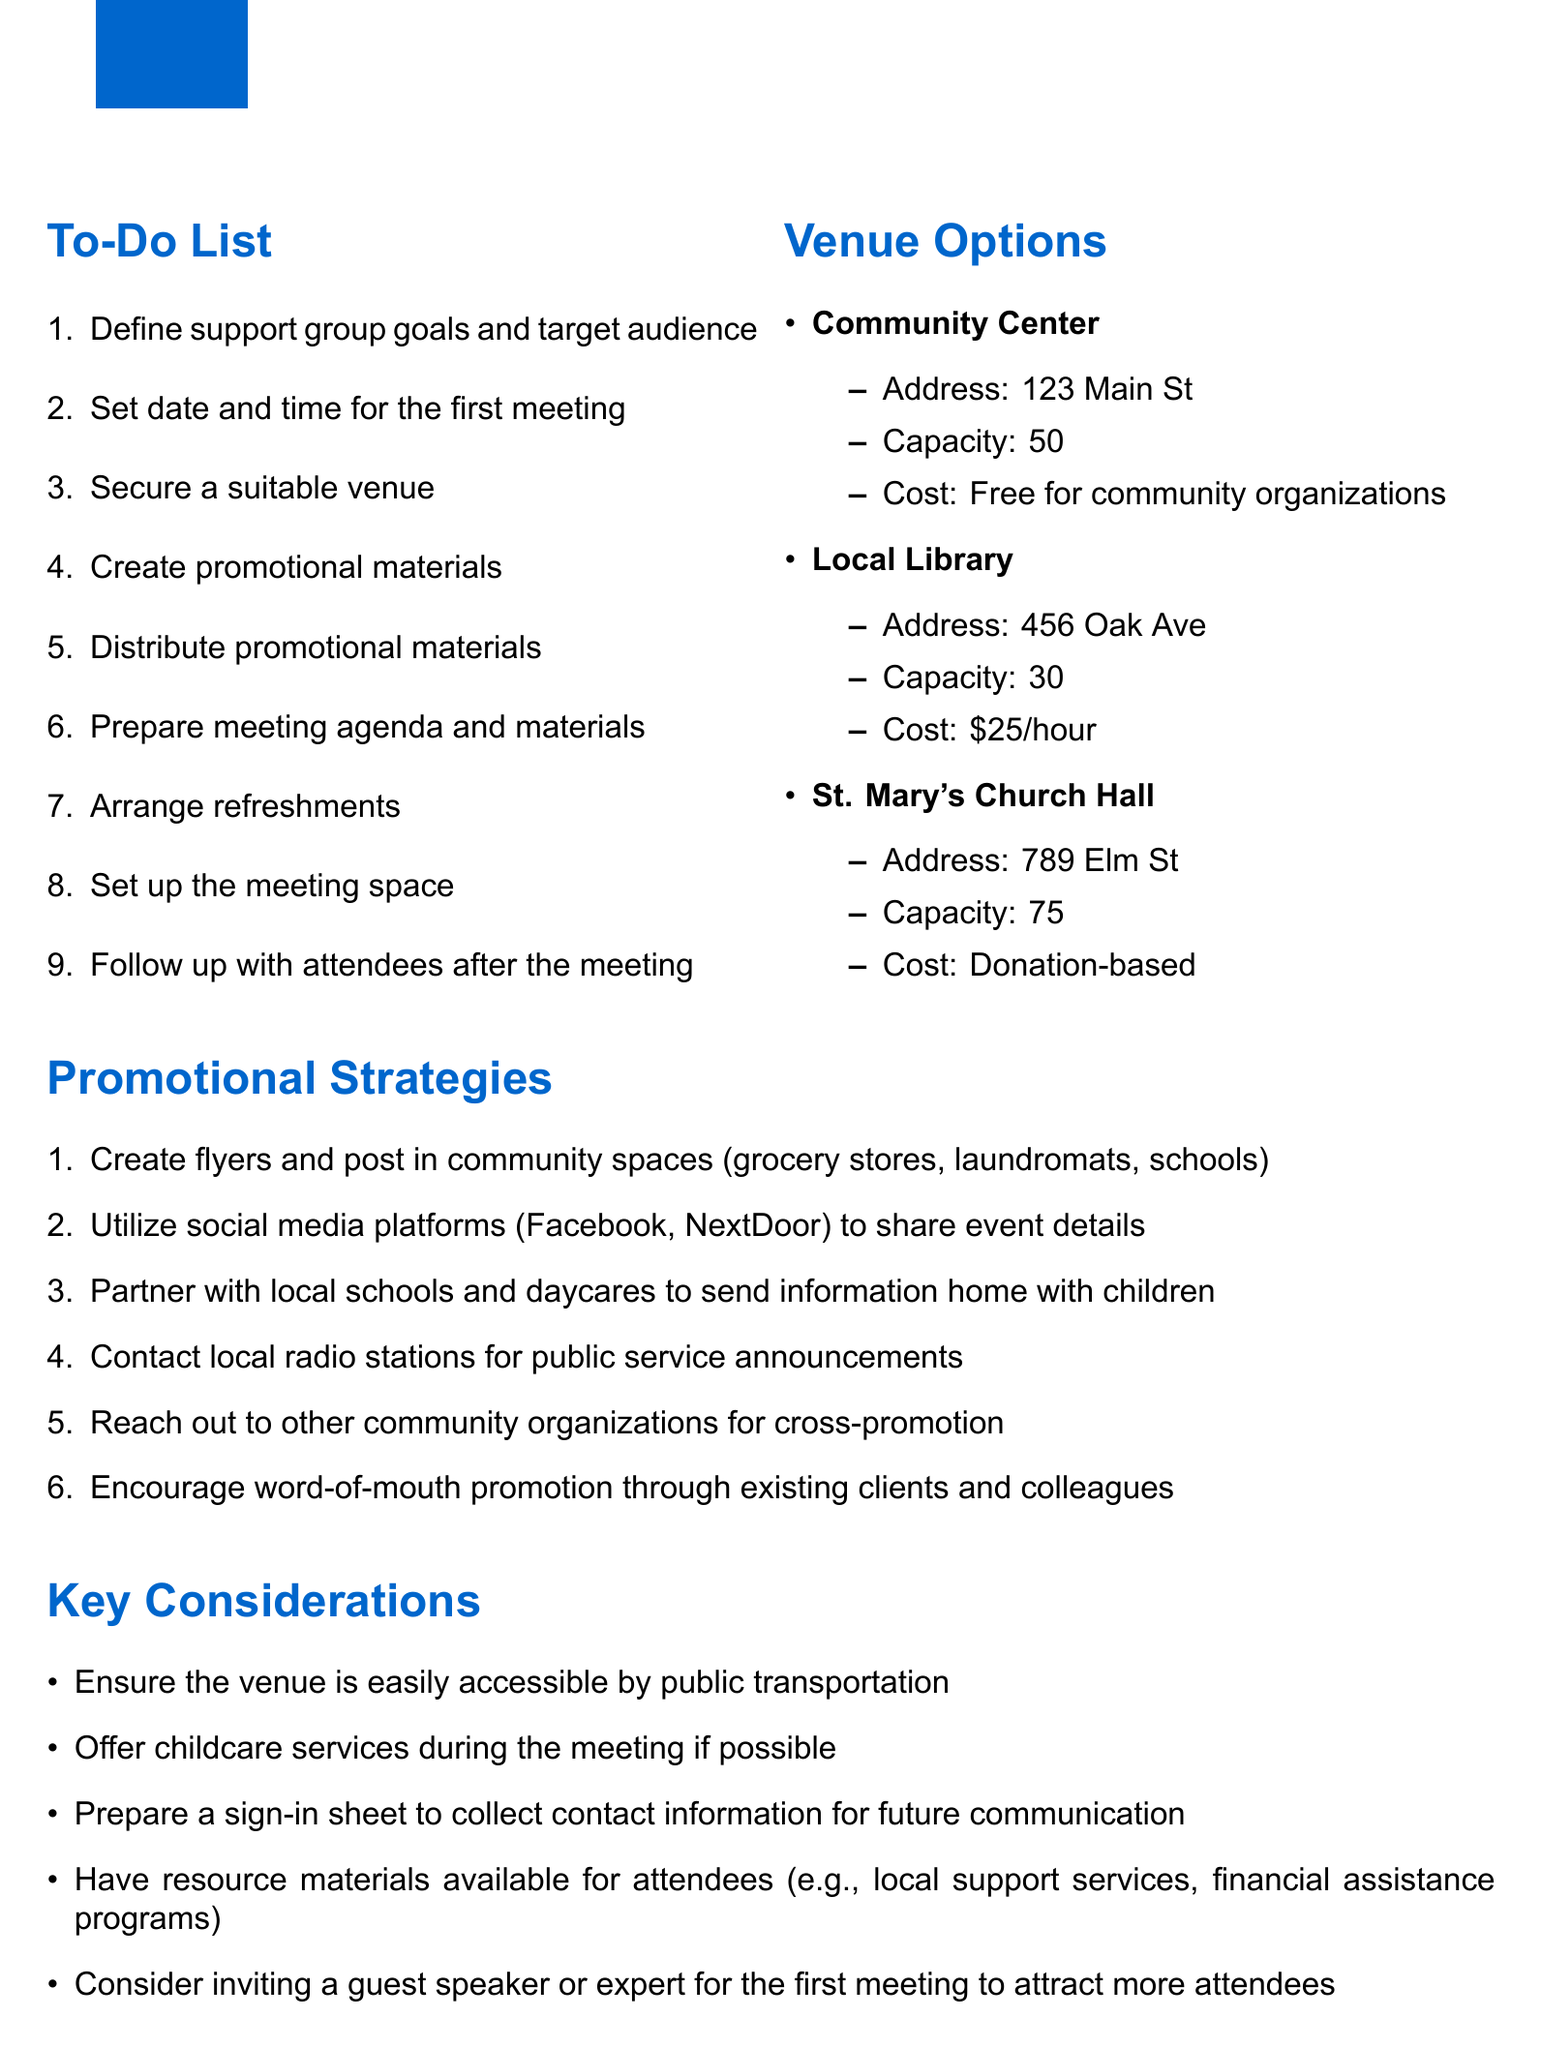What is the first item on the to-do list? The first item on the to-do list is to define support group goals and target audience.
Answer: Define support group goals and target audience How many venue options are listed? The document lists three venue options for the support group meeting.
Answer: 3 What is the capacity of St. Mary's Church Hall? The capacity of St. Mary's Church Hall is stated in the venue options section of the document.
Answer: 75 What is the estimated cost of renting the Local Library? The cost associated with the Local Library is mentioned under venue options.
Answer: $25/hour Which promotional strategy involves local schools? The document specifies a promotional strategy that mentions partnering with local schools to send information home.
Answer: Partner with local schools and daycares to send information home with children What is a key consideration regarding venue accessibility? The key considerations note that the venue should be accessible by public transportation.
Answer: Ensure the venue is easily accessible by public transportation What type of materials should be available for attendees? The document highlights the necessity of resource materials for attendees in the key considerations section.
Answer: Have resource materials available for attendees What should be prepared to collect attendee information? The key considerations include the need to prepare a specific document for gathering attendee details.
Answer: Prepare a sign-in sheet to collect contact information for future communication 